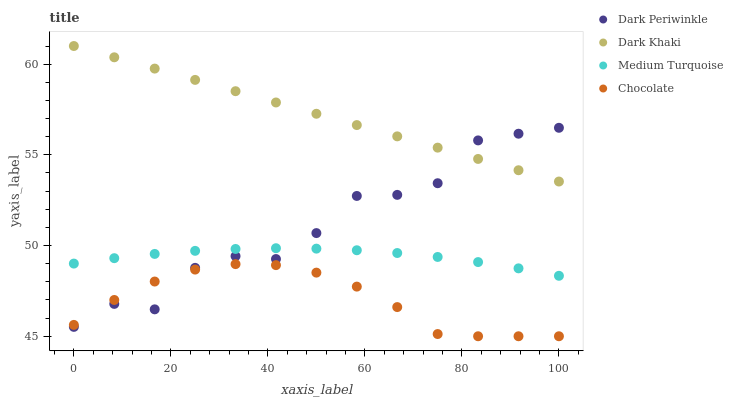Does Chocolate have the minimum area under the curve?
Answer yes or no. Yes. Does Dark Khaki have the maximum area under the curve?
Answer yes or no. Yes. Does Dark Periwinkle have the minimum area under the curve?
Answer yes or no. No. Does Dark Periwinkle have the maximum area under the curve?
Answer yes or no. No. Is Dark Khaki the smoothest?
Answer yes or no. Yes. Is Dark Periwinkle the roughest?
Answer yes or no. Yes. Is Medium Turquoise the smoothest?
Answer yes or no. No. Is Medium Turquoise the roughest?
Answer yes or no. No. Does Chocolate have the lowest value?
Answer yes or no. Yes. Does Dark Periwinkle have the lowest value?
Answer yes or no. No. Does Dark Khaki have the highest value?
Answer yes or no. Yes. Does Dark Periwinkle have the highest value?
Answer yes or no. No. Is Medium Turquoise less than Dark Khaki?
Answer yes or no. Yes. Is Dark Khaki greater than Medium Turquoise?
Answer yes or no. Yes. Does Chocolate intersect Dark Periwinkle?
Answer yes or no. Yes. Is Chocolate less than Dark Periwinkle?
Answer yes or no. No. Is Chocolate greater than Dark Periwinkle?
Answer yes or no. No. Does Medium Turquoise intersect Dark Khaki?
Answer yes or no. No. 